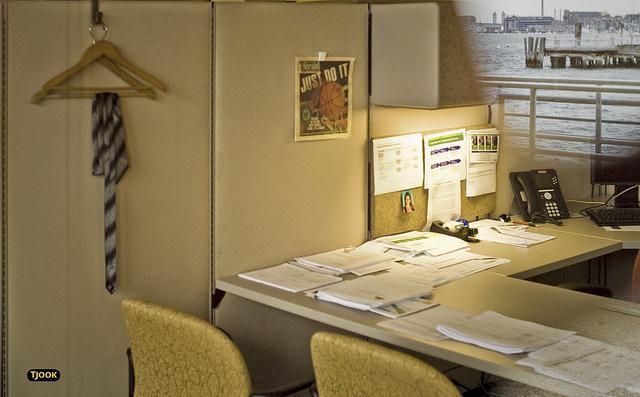How many chairs are in the photo?
Give a very brief answer. 2. How many ties are in the picture?
Give a very brief answer. 1. How many people are in the crowd to the left of the skater?
Give a very brief answer. 0. 